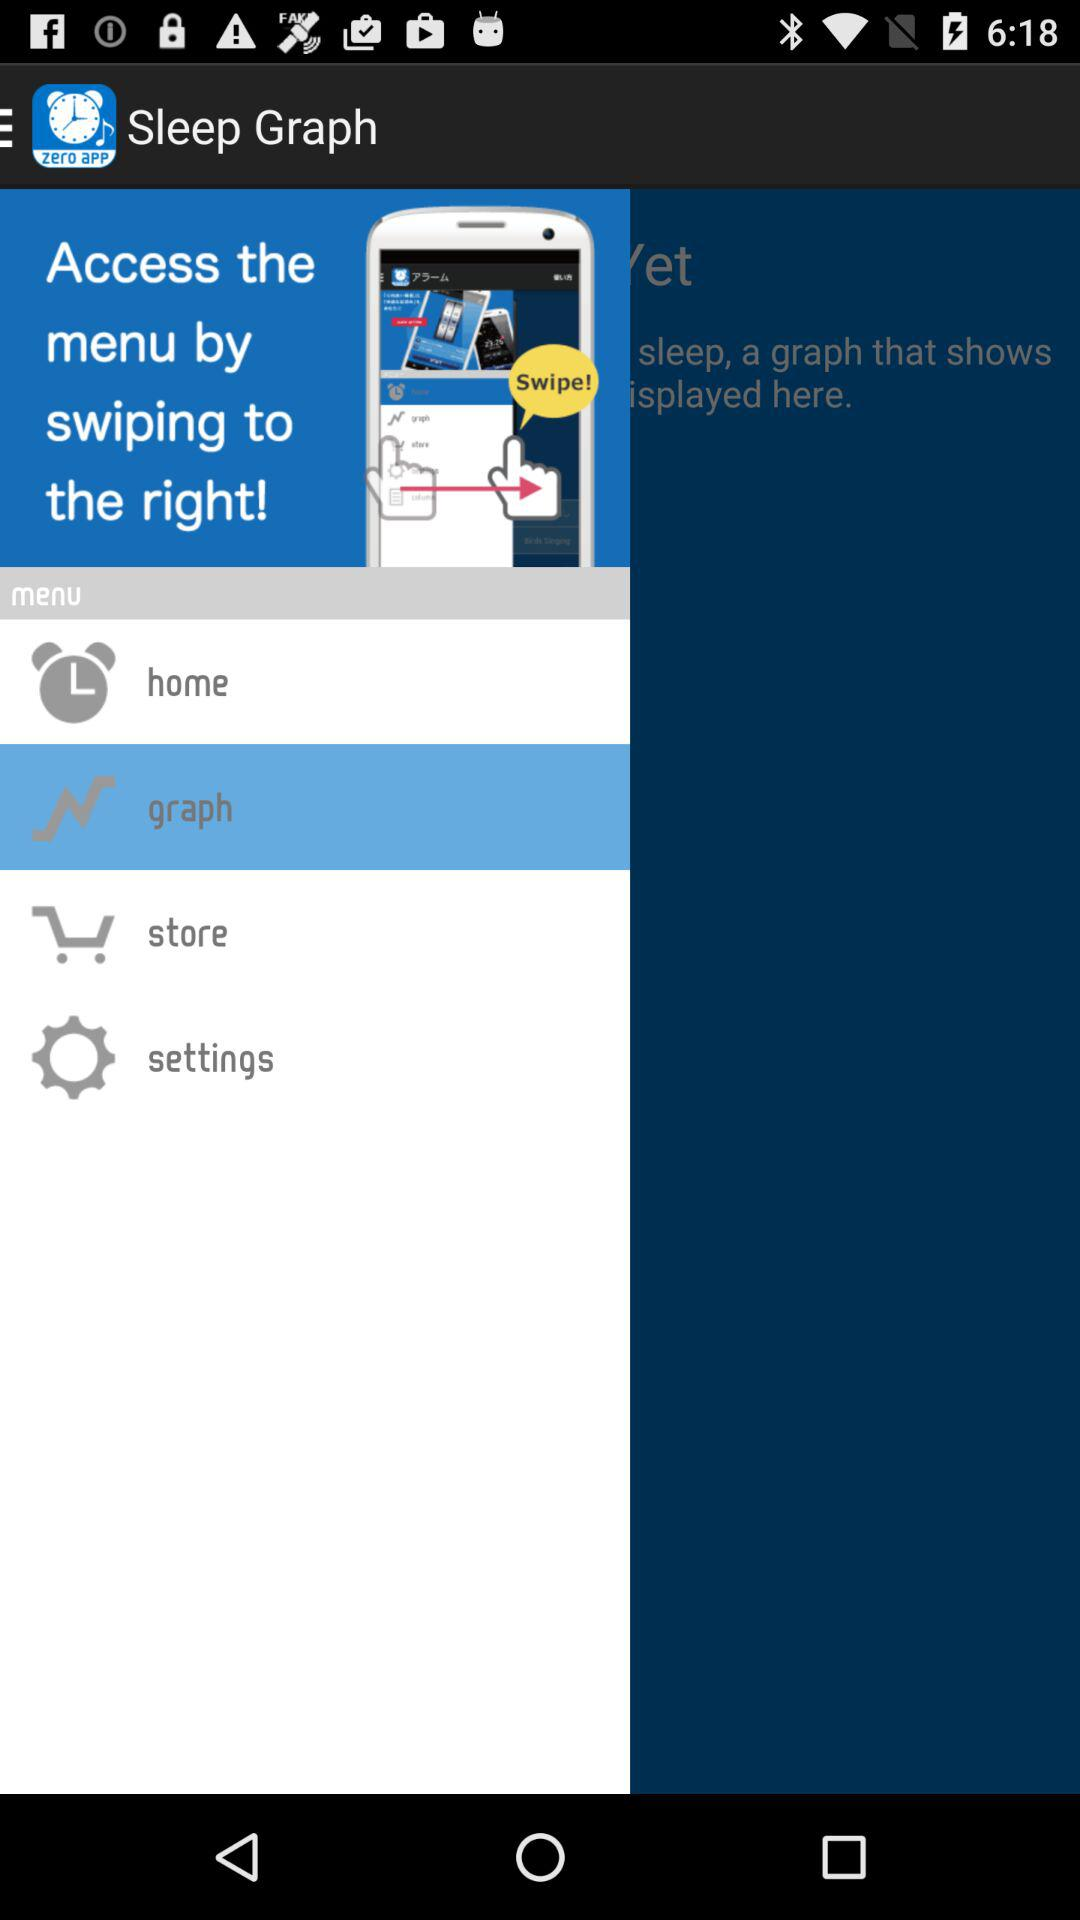What is the name of the application? The name of the application is "Good Night's Sleep Alarm". 